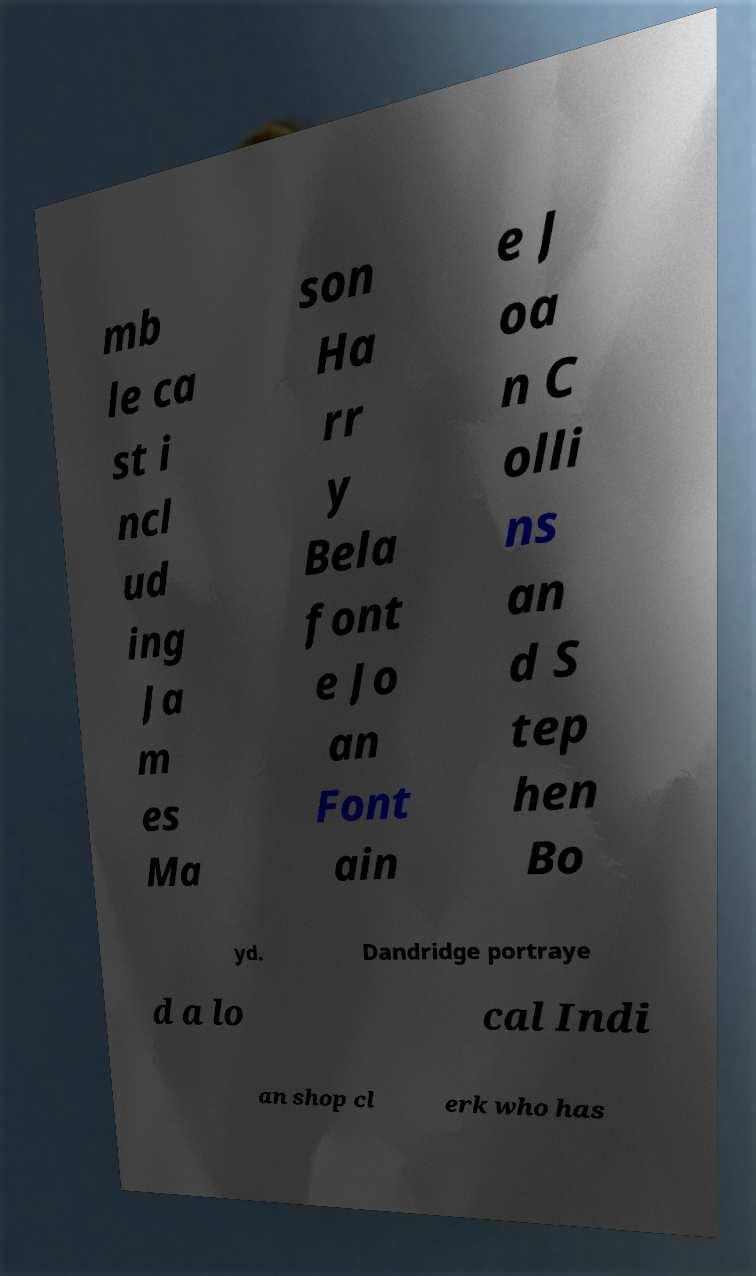Please read and relay the text visible in this image. What does it say? mb le ca st i ncl ud ing Ja m es Ma son Ha rr y Bela font e Jo an Font ain e J oa n C olli ns an d S tep hen Bo yd. Dandridge portraye d a lo cal Indi an shop cl erk who has 